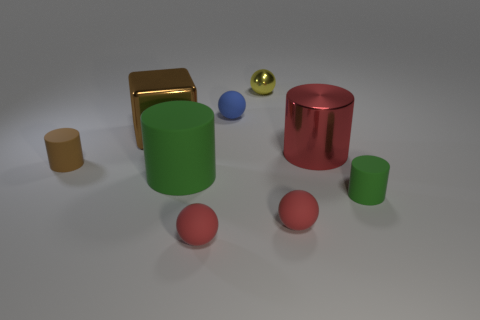How many green cylinders must be subtracted to get 1 green cylinders? 1 Subtract all cyan spheres. How many green cylinders are left? 2 Subtract all matte balls. How many balls are left? 1 Subtract all yellow spheres. How many spheres are left? 3 Subtract all yellow cylinders. Subtract all green balls. How many cylinders are left? 4 Subtract all balls. How many objects are left? 5 Add 3 big rubber cylinders. How many big rubber cylinders exist? 4 Subtract 0 yellow cylinders. How many objects are left? 9 Subtract all purple spheres. Subtract all metal spheres. How many objects are left? 8 Add 3 small spheres. How many small spheres are left? 7 